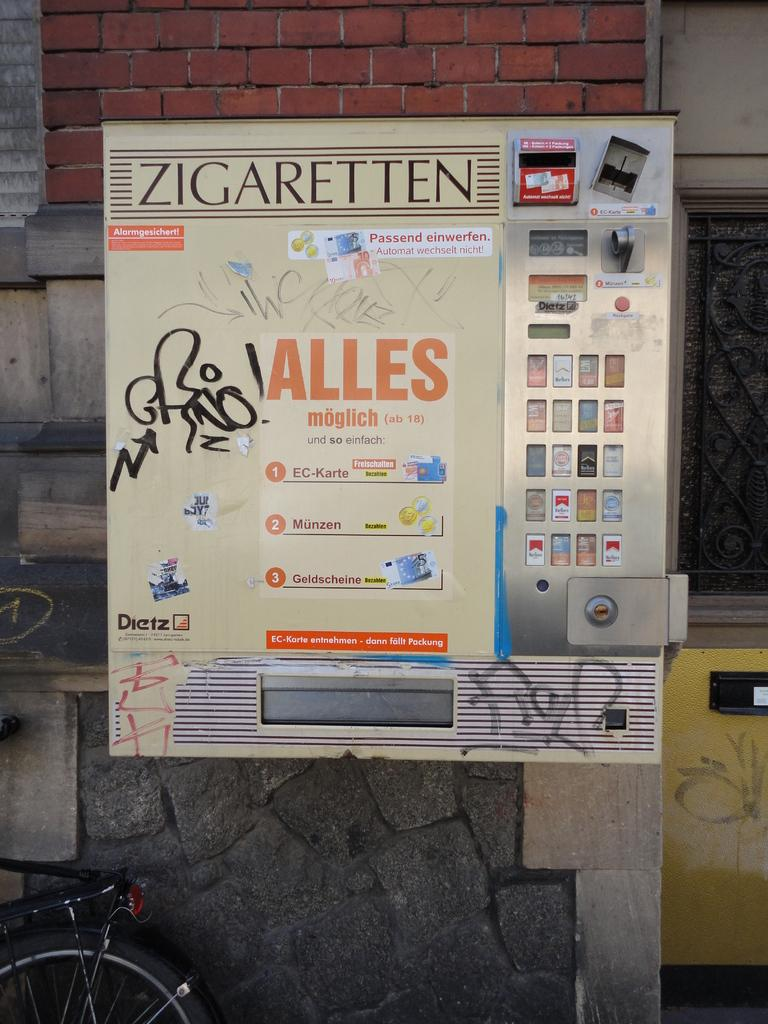<image>
Present a compact description of the photo's key features. Zigaretten can be purchased from an outdoor vending machine. 